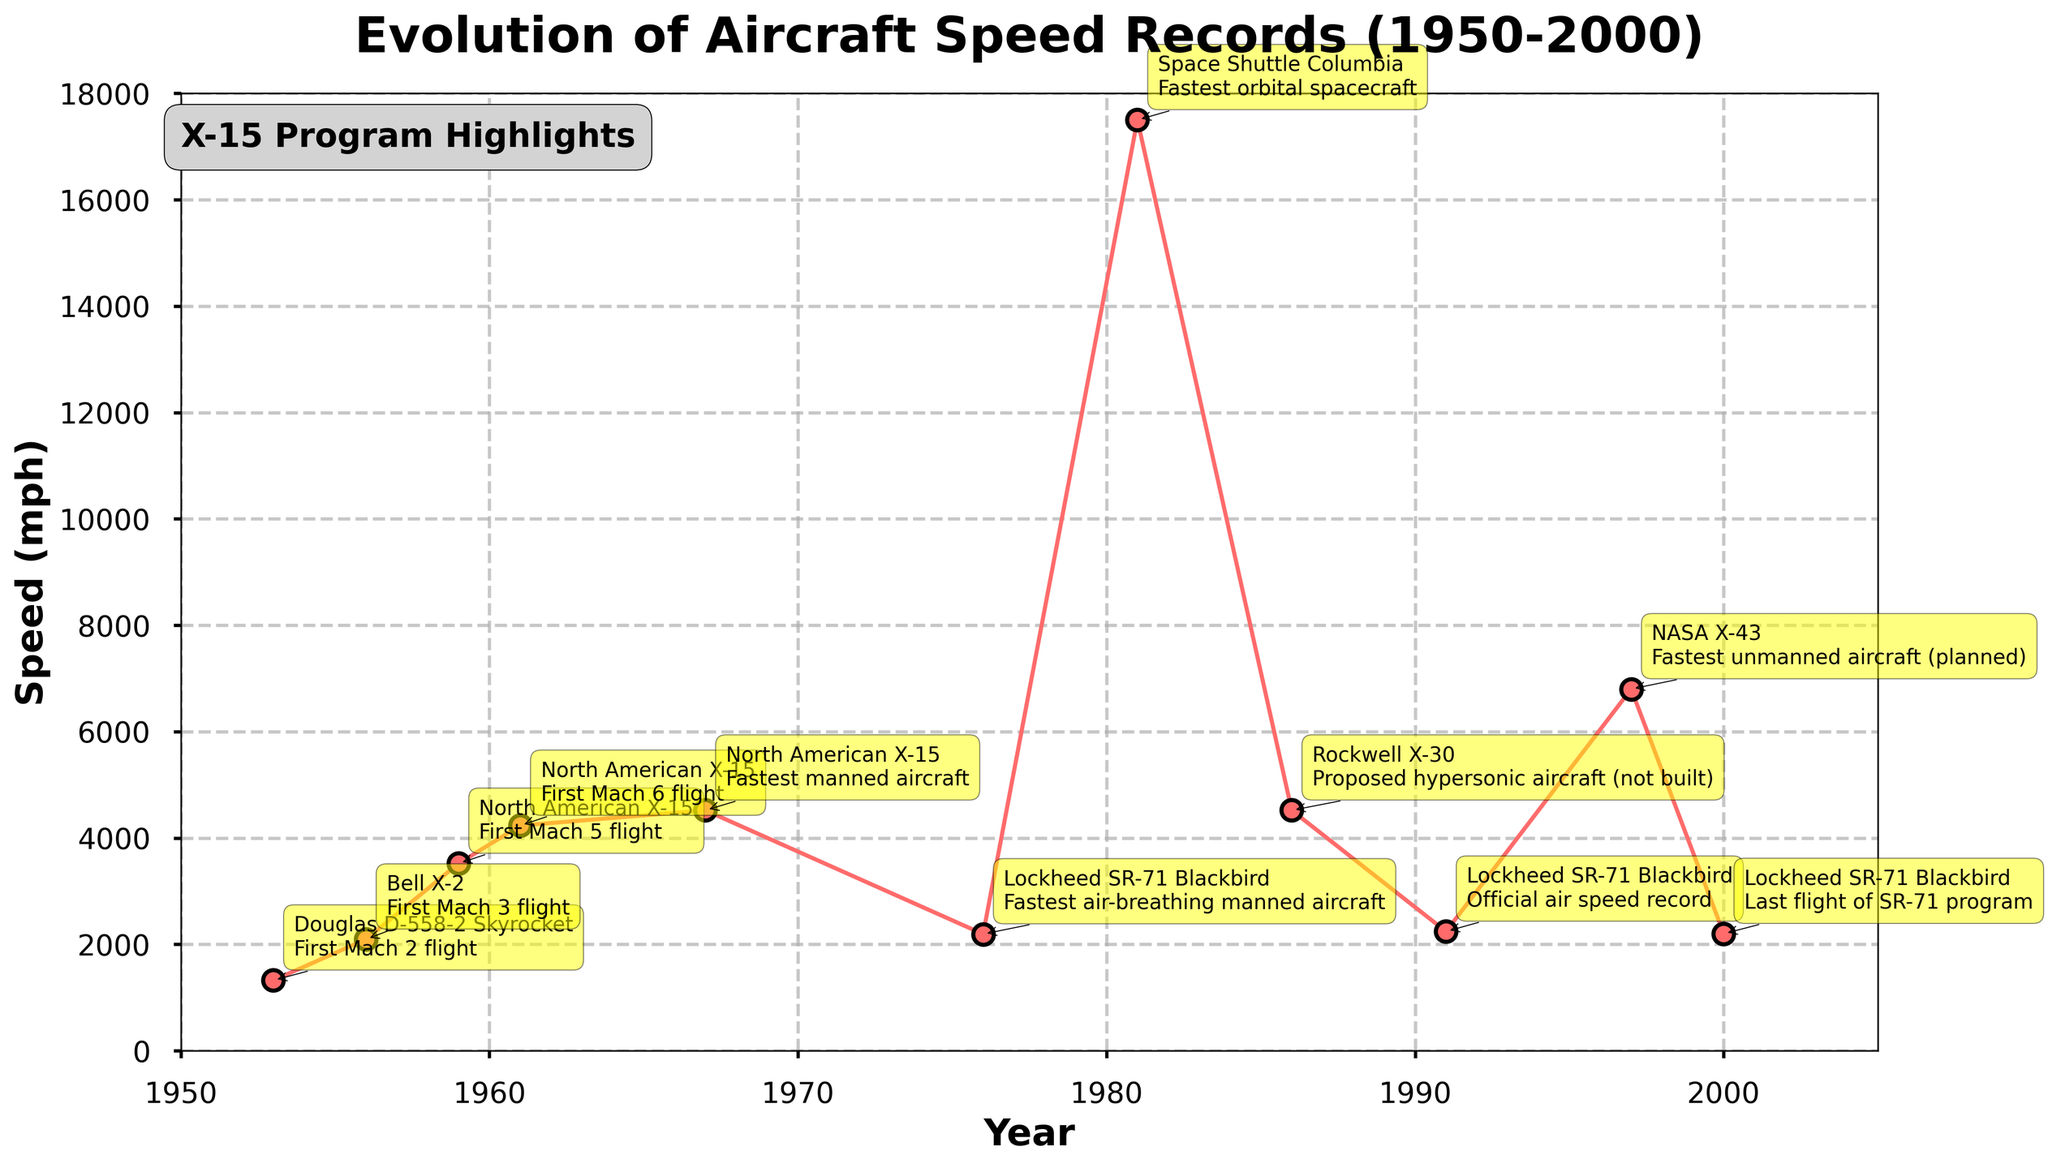Which aircraft achieved the first Mach 2 flight, and in what year did it happen? The plot shows a milestone annotation for the first Mach 2 flight. By reading the highlighted text, it's noted that the Douglas D-558-2 Skyrocket achieved this milestone in 1953.
Answer: Douglas D-558-2 Skyrocket, 1953 How much faster was the North American X-15's fastest speed compared to its first Mach 5 flight? First, locate the speeds for the North American X-15's first Mach 5 flight (3519 mph) and its fastest speed (4520 mph). Subtract the two values: 4520 - 3519 = 1001 mph.
Answer: 1001 mph Which aircraft set the speed record in the year 1976, and what was its speed? The plot highlights a speed record in 1976, showing that the Lockheed SR-71 Blackbird set this record with a speed of 2193 mph.
Answer: Lockheed SR-71 Blackbird, 2193 mph Which milestone indicates the fastest unmanned aircraft and what year was it planned for? Refer to the data and annotations; the fastest unmanned aircraft is the NASA X-43, planned for 1997.
Answer: NASA X-43, 1997 Compare the official air speed record of the Lockheed SR-71 Blackbird in 1991 to the speed in its last flight in 2000. Which was faster? Locate the speeds for the Lockheed SR-71 Blackbird in 1991 (2242 mph) and in 2000 (2200 mph). By comparing these values, the speed in 1991 was faster.
Answer: 1991 Which aircraft holds the title for the "Fastest manned aircraft" and what is its speed? From the annotations, the "Fastest manned aircraft" title belongs to the North American X-15 with a speed of 4520 mph.
Answer: North American X-15, 4520 mph How many aircraft set speed milestones between 1960 and 1980? Looking at the plot and focusing on the years between 1960 and 1980, you'll identify milestones for the North American X-15 in 1961 and 1967, and for the Lockheed SR-71 Blackbird in 1976. There are 3 milestones in this range.
Answer: 3 What is the difference in speed between the fastest air-breathing manned aircraft and the fastest orbital spacecraft? From the data, the fastest air-breathing manned aircraft is the Lockheed SR-71 Blackbird at 2193 mph (1976), and the fastest orbital spacecraft is the Space Shuttle Columbia at 17500 mph (1981). The difference is 17500 - 2193 = 15307 mph.
Answer: 15307 mph 